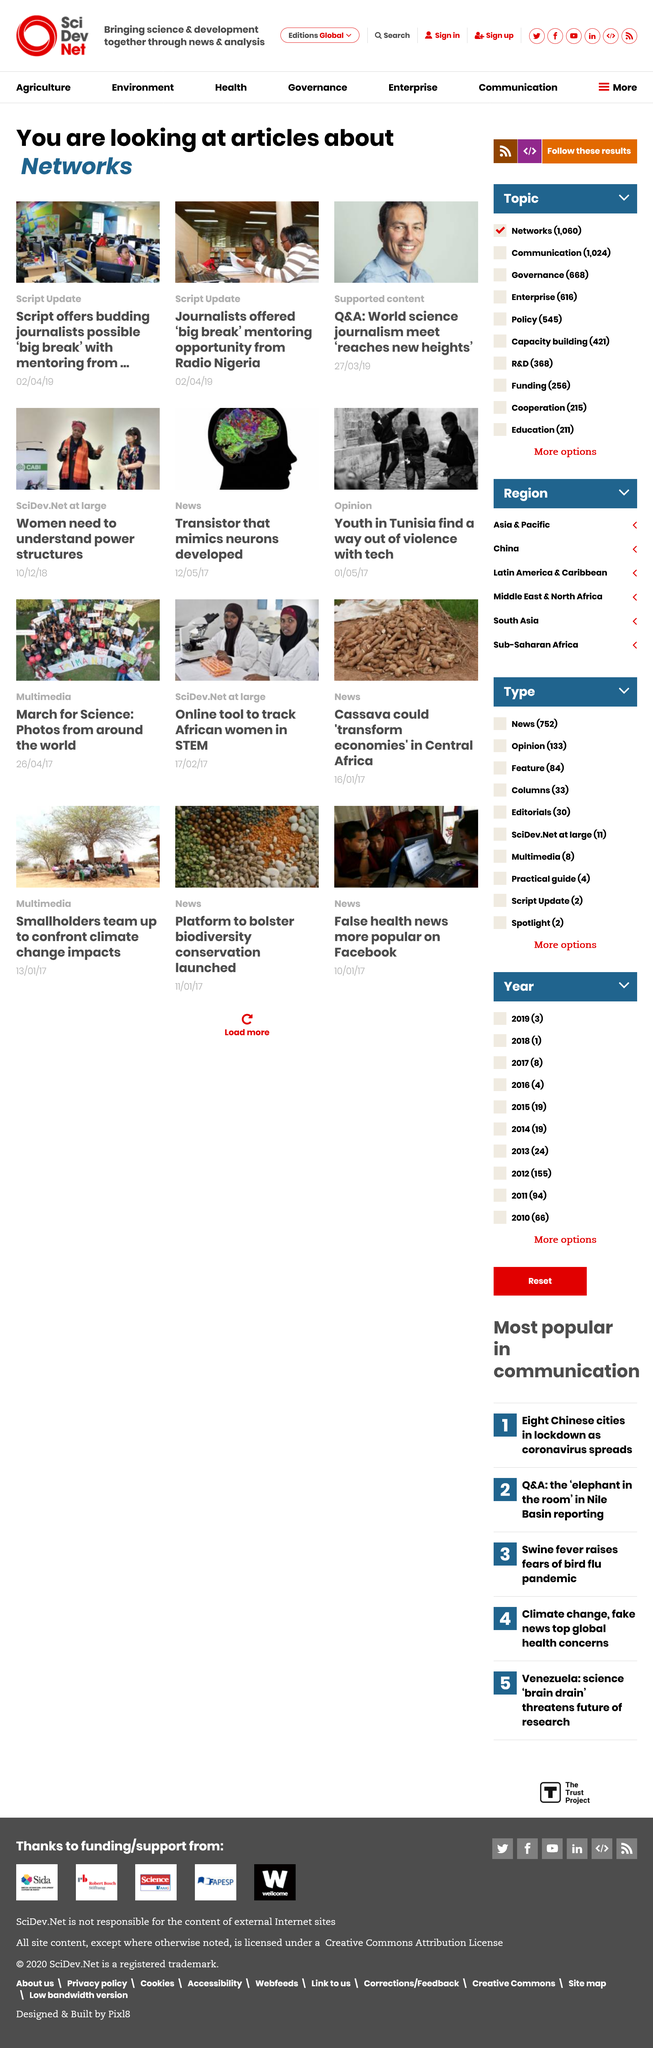List a handful of essential elements in this visual. The supported content article was published on March 27, 2019. The types of articles being considered are networks. Radio Nigeria has offered a "big break" mentoring opportunity to journalists. 